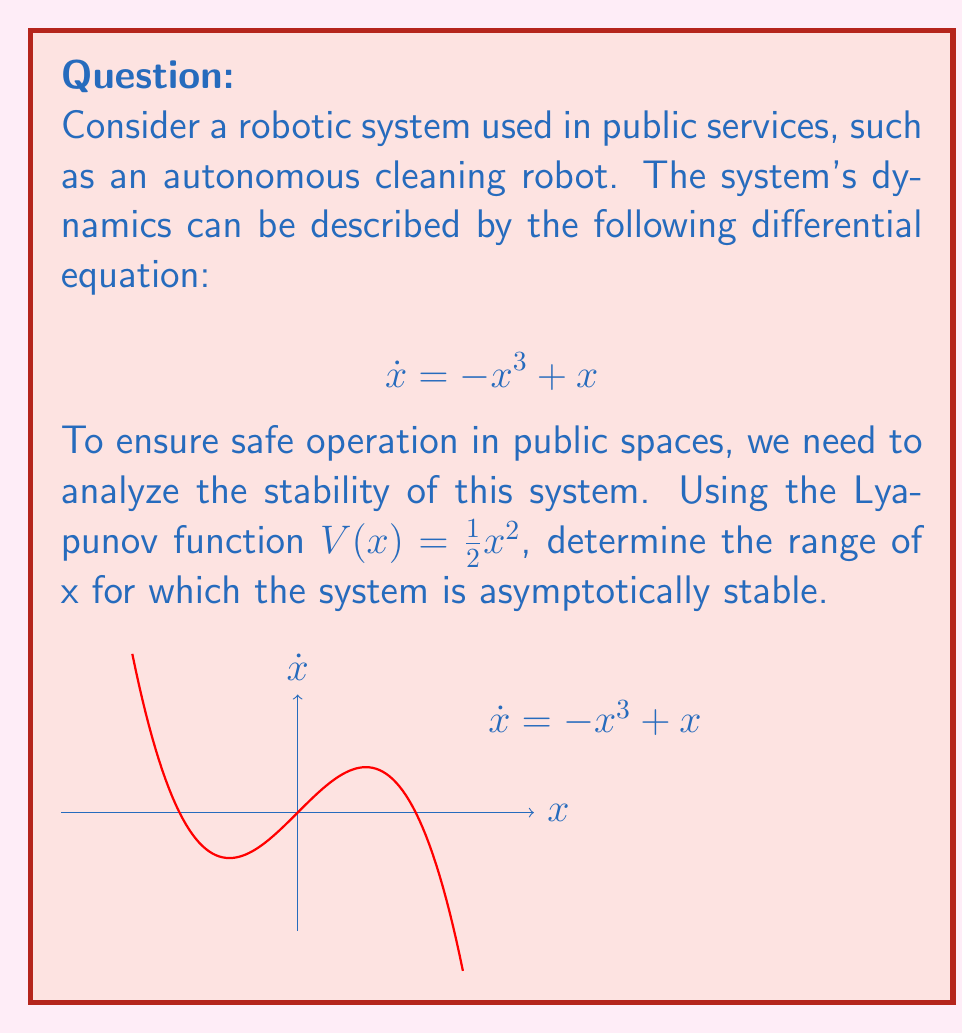Teach me how to tackle this problem. To analyze the stability of the system using Lyapunov's direct method, we follow these steps:

1) We have the Lyapunov function $V(x) = \frac{1}{2}x^2$. This function is positive definite for all $x \neq 0$.

2) Calculate the derivative of $V$ along the system trajectories:

   $$\dot{V}(x) = \frac{dV}{dx}\dot{x} = x\dot{x} = x(-x^3 + x) = -x^4 + x^2$$

3) For asymptotic stability, we need $\dot{V}(x) < 0$ for $x \neq 0$. Let's solve this inequality:

   $$-x^4 + x^2 < 0$$
   $$x^2(-x^2 + 1) < 0$$

4) This inequality is satisfied when:
   
   $x^2 > 0$ (always true for $x \neq 0$) and $-x^2 + 1 < 0$
   
   Solving $-x^2 + 1 < 0$:
   $x^2 > 1$
   $|x| > 1$

5) Therefore, the system is asymptotically stable for $|x| < 1$, excluding $x = 0$.

This result indicates that the autonomous cleaning robot will reliably return to its equilibrium state when its state variable is within the range $-1 < x < 1$, excluding $x = 0$. This information is crucial for setting safe operational limits in public spaces.
Answer: $-1 < x < 1$, $x \neq 0$ 